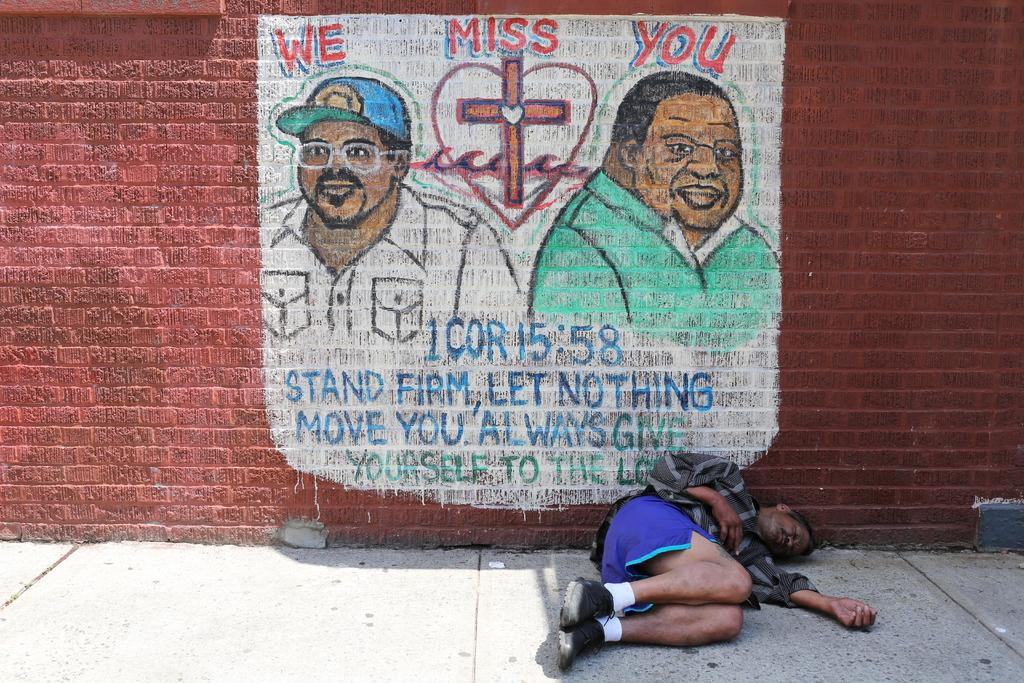<image>
Render a clear and concise summary of the photo. A man sleeping on a sidewalk underneath a poster stating we miss you. 